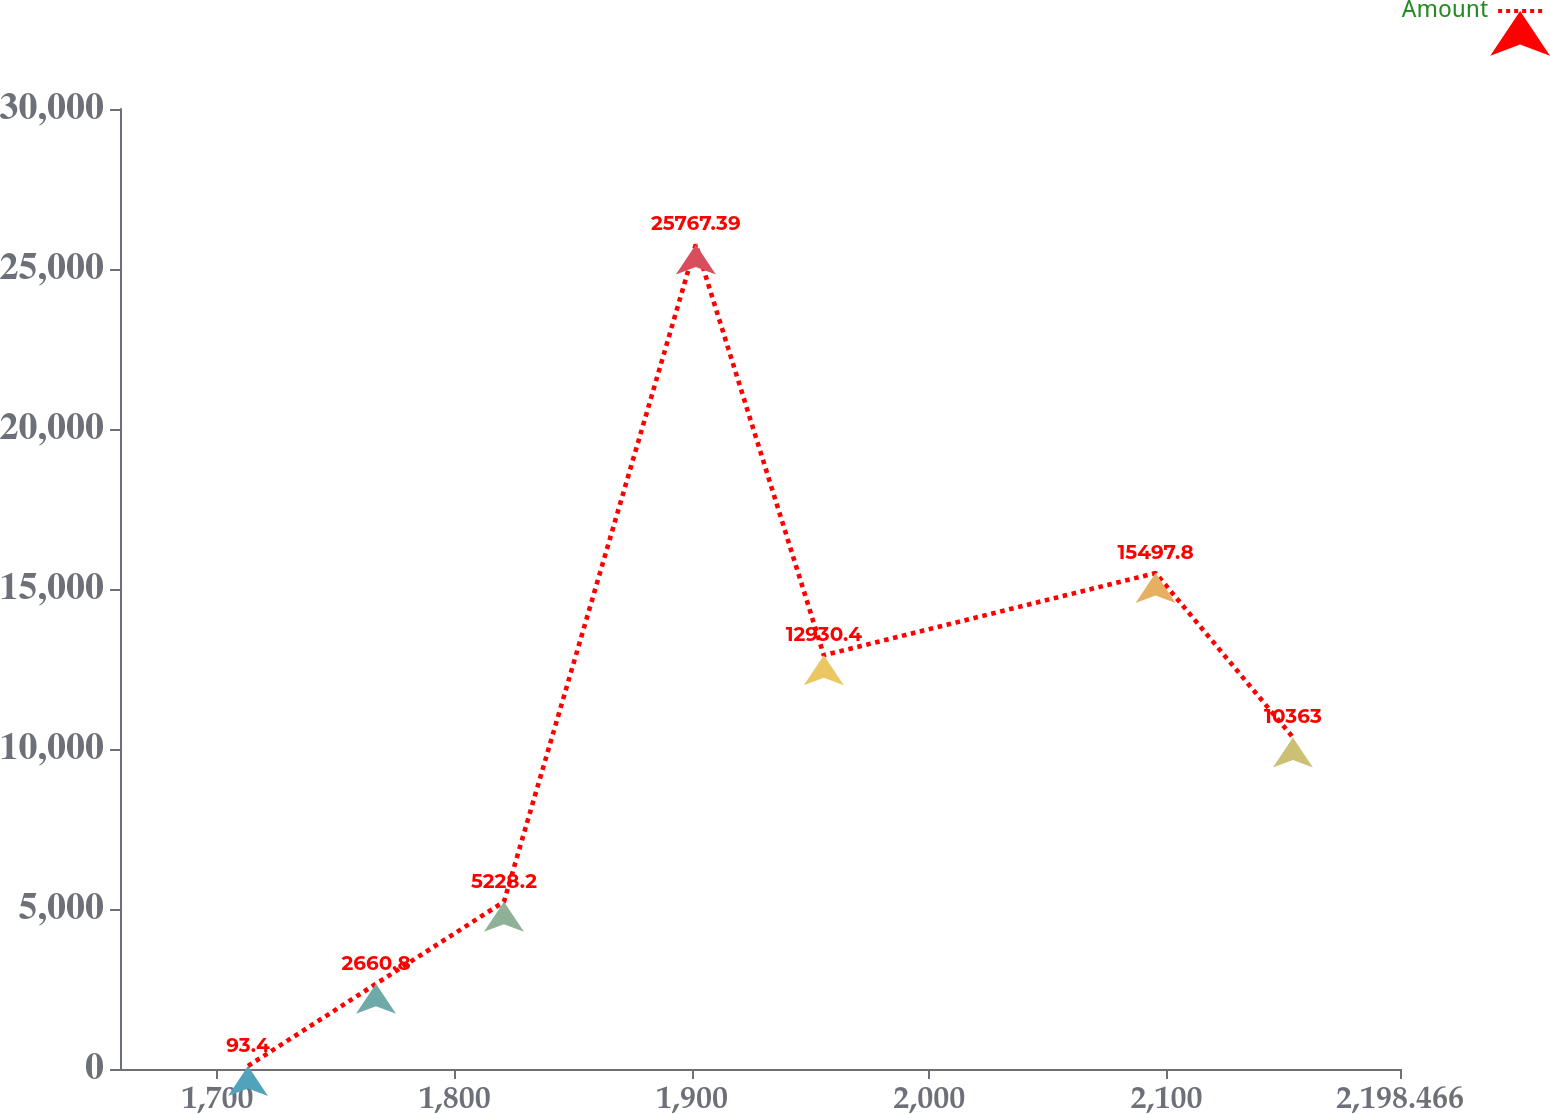Convert chart. <chart><loc_0><loc_0><loc_500><loc_500><line_chart><ecel><fcel>Amount<nl><fcel>1712.88<fcel>93.4<nl><fcel>1766.83<fcel>2660.8<nl><fcel>1820.78<fcel>5228.2<nl><fcel>1901.65<fcel>25767.4<nl><fcel>1955.6<fcel>12930.4<nl><fcel>2095.44<fcel>15497.8<nl><fcel>2153.33<fcel>10363<nl><fcel>2252.42<fcel>7795.6<nl></chart> 